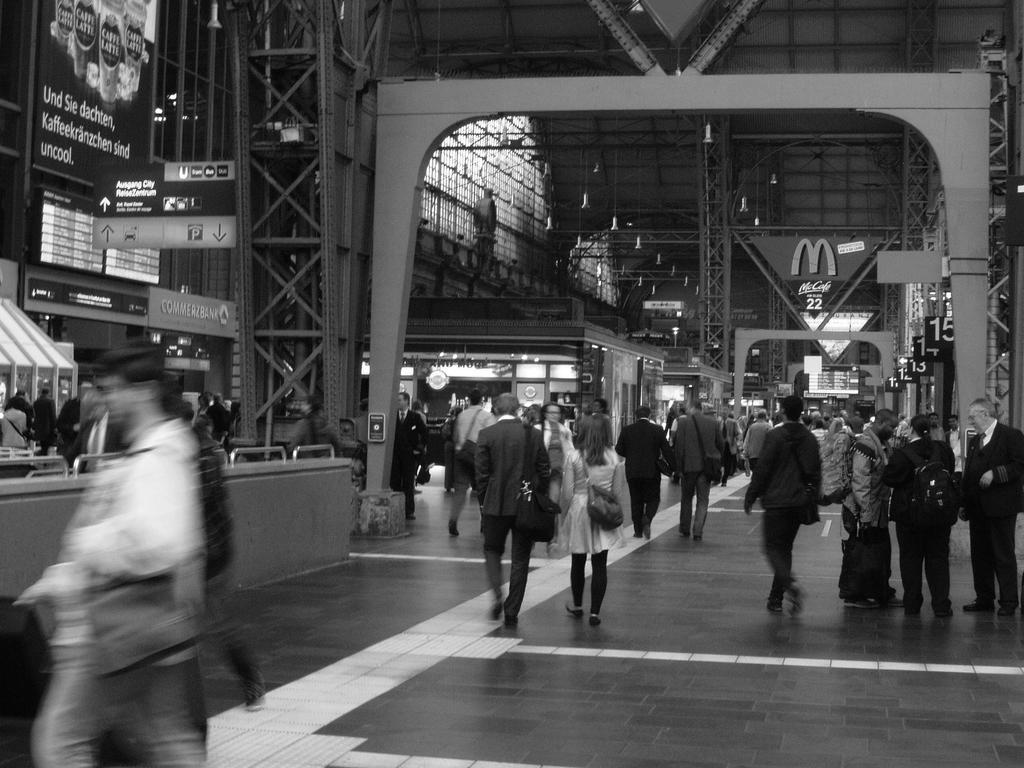Can you describe this image briefly? In this image we can see many people. Some are walking. Some are wearing bags. Also there are buildings. There are sign boards. There are boards with some text. And there are arches and lights. 